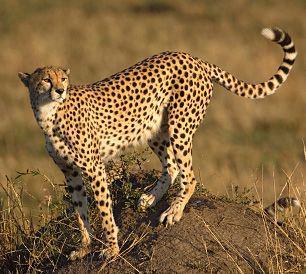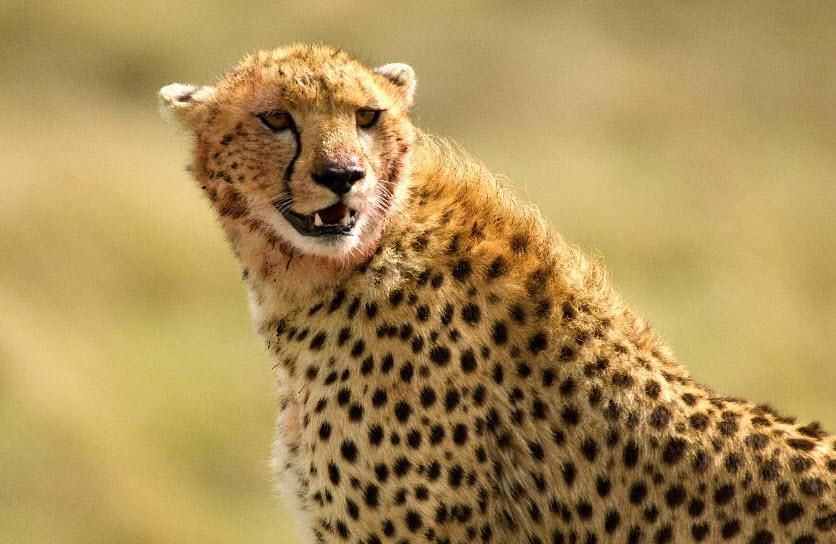The first image is the image on the left, the second image is the image on the right. Analyze the images presented: Is the assertion "At least one cheetah is laying down." valid? Answer yes or no. No. 